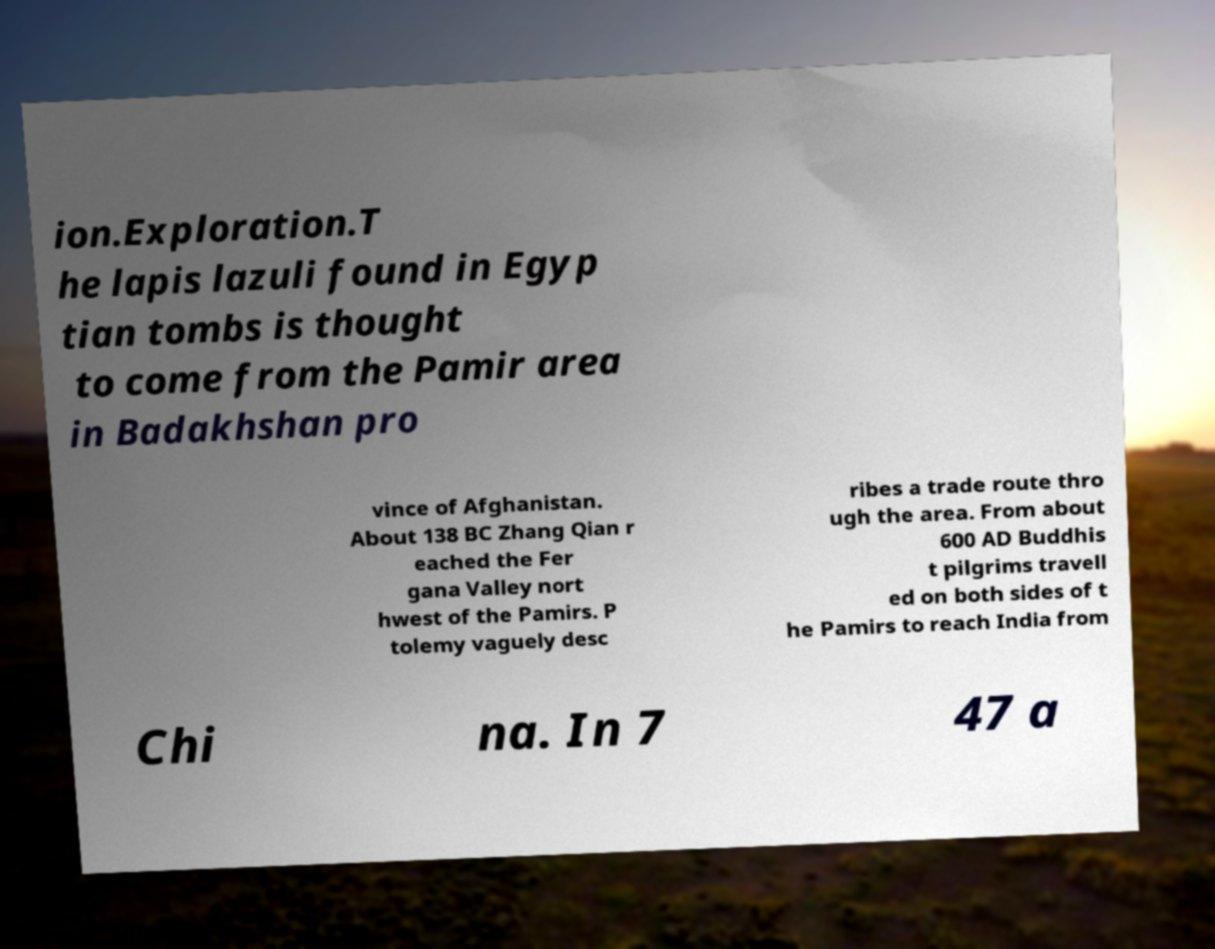Please read and relay the text visible in this image. What does it say? ion.Exploration.T he lapis lazuli found in Egyp tian tombs is thought to come from the Pamir area in Badakhshan pro vince of Afghanistan. About 138 BC Zhang Qian r eached the Fer gana Valley nort hwest of the Pamirs. P tolemy vaguely desc ribes a trade route thro ugh the area. From about 600 AD Buddhis t pilgrims travell ed on both sides of t he Pamirs to reach India from Chi na. In 7 47 a 